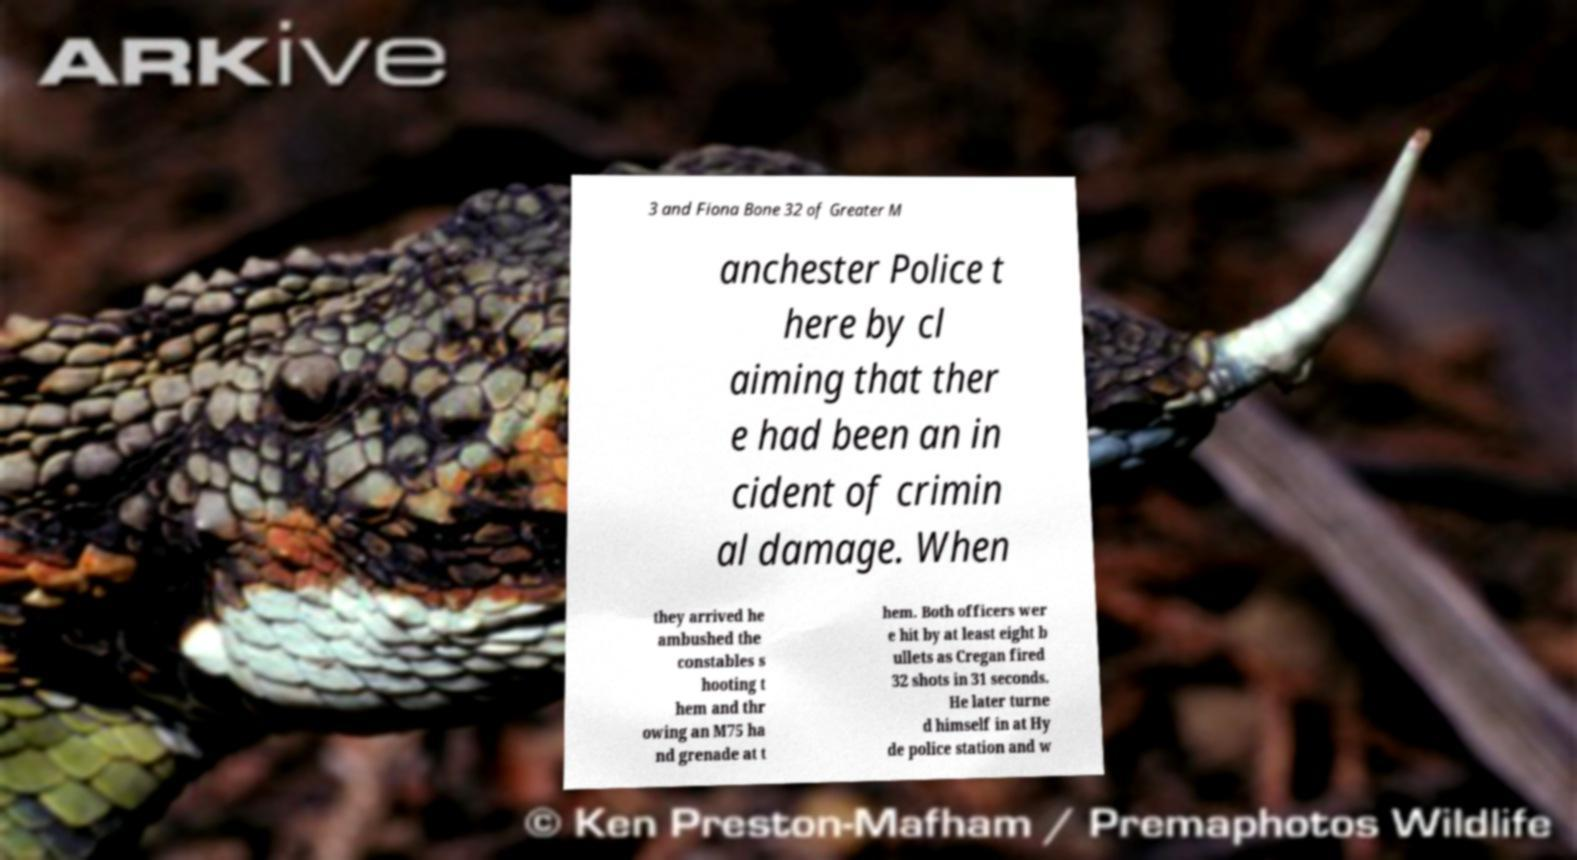Could you assist in decoding the text presented in this image and type it out clearly? 3 and Fiona Bone 32 of Greater M anchester Police t here by cl aiming that ther e had been an in cident of crimin al damage. When they arrived he ambushed the constables s hooting t hem and thr owing an M75 ha nd grenade at t hem. Both officers wer e hit by at least eight b ullets as Cregan fired 32 shots in 31 seconds. He later turne d himself in at Hy de police station and w 